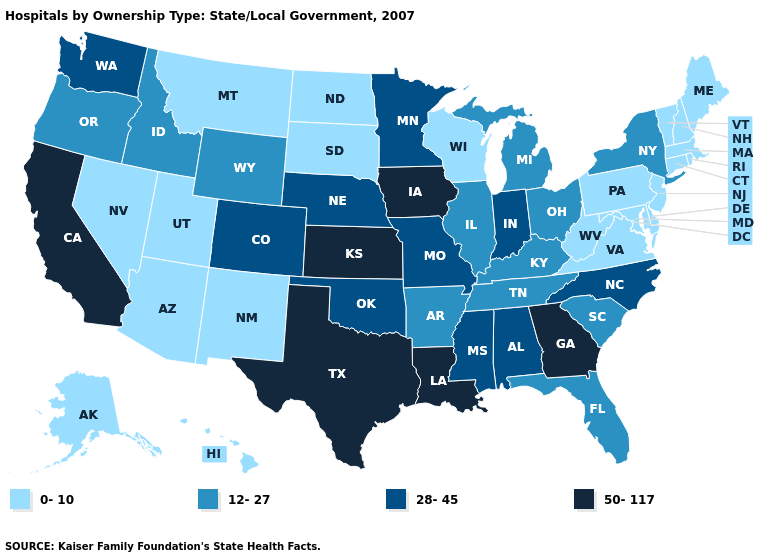What is the highest value in the USA?
Keep it brief. 50-117. How many symbols are there in the legend?
Quick response, please. 4. Among the states that border Delaware , which have the highest value?
Short answer required. Maryland, New Jersey, Pennsylvania. Which states have the lowest value in the USA?
Keep it brief. Alaska, Arizona, Connecticut, Delaware, Hawaii, Maine, Maryland, Massachusetts, Montana, Nevada, New Hampshire, New Jersey, New Mexico, North Dakota, Pennsylvania, Rhode Island, South Dakota, Utah, Vermont, Virginia, West Virginia, Wisconsin. Name the states that have a value in the range 50-117?
Short answer required. California, Georgia, Iowa, Kansas, Louisiana, Texas. Does Hawaii have the highest value in the USA?
Give a very brief answer. No. What is the value of North Carolina?
Short answer required. 28-45. What is the highest value in states that border Nevada?
Give a very brief answer. 50-117. Which states hav the highest value in the West?
Write a very short answer. California. What is the highest value in the USA?
Short answer required. 50-117. What is the value of Iowa?
Short answer required. 50-117. Name the states that have a value in the range 28-45?
Give a very brief answer. Alabama, Colorado, Indiana, Minnesota, Mississippi, Missouri, Nebraska, North Carolina, Oklahoma, Washington. Among the states that border West Virginia , does Kentucky have the lowest value?
Write a very short answer. No. Which states have the highest value in the USA?
Write a very short answer. California, Georgia, Iowa, Kansas, Louisiana, Texas. Is the legend a continuous bar?
Give a very brief answer. No. 